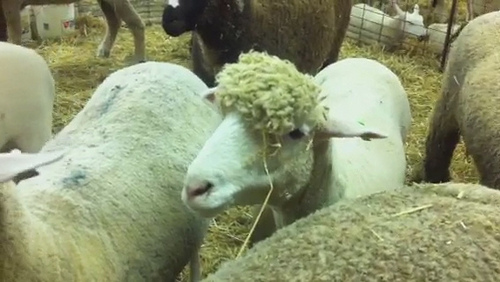Which place is it? It is a pen. 